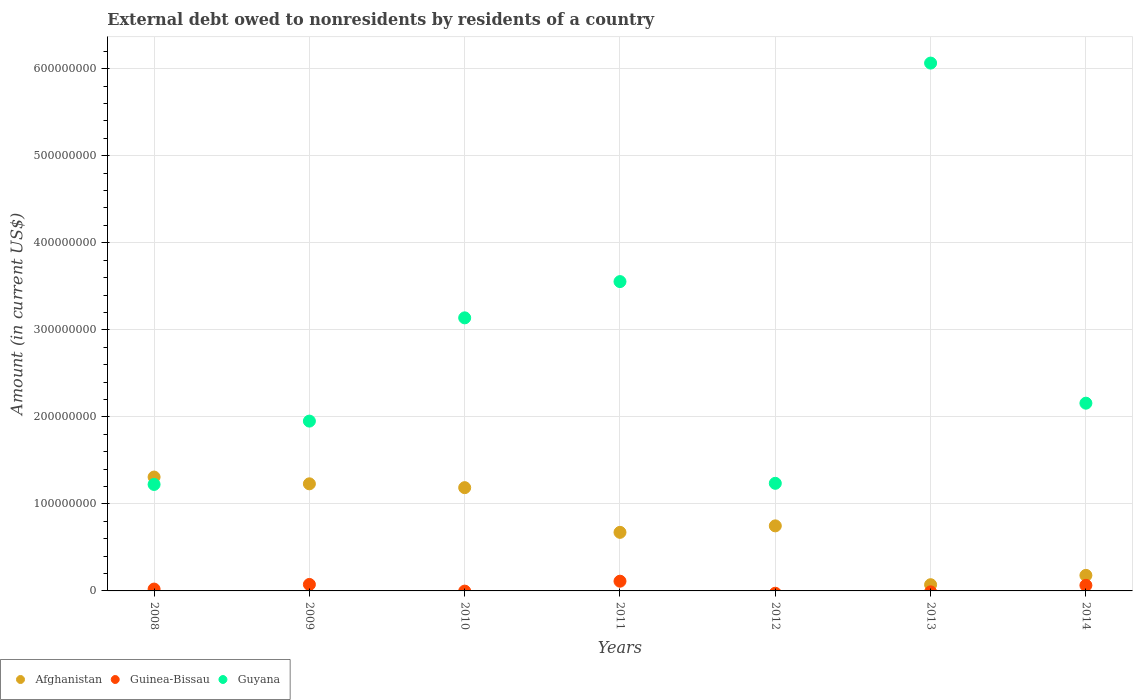How many different coloured dotlines are there?
Provide a succinct answer. 3. Is the number of dotlines equal to the number of legend labels?
Make the answer very short. No. What is the external debt owed by residents in Guyana in 2013?
Your response must be concise. 6.07e+08. Across all years, what is the maximum external debt owed by residents in Guyana?
Provide a succinct answer. 6.07e+08. Across all years, what is the minimum external debt owed by residents in Guinea-Bissau?
Your answer should be compact. 0. What is the total external debt owed by residents in Afghanistan in the graph?
Ensure brevity in your answer.  5.40e+08. What is the difference between the external debt owed by residents in Afghanistan in 2011 and that in 2013?
Ensure brevity in your answer.  6.02e+07. What is the difference between the external debt owed by residents in Afghanistan in 2014 and the external debt owed by residents in Guyana in 2012?
Offer a very short reply. -1.06e+08. What is the average external debt owed by residents in Guyana per year?
Make the answer very short. 2.76e+08. In the year 2014, what is the difference between the external debt owed by residents in Afghanistan and external debt owed by residents in Guinea-Bissau?
Offer a very short reply. 1.15e+07. In how many years, is the external debt owed by residents in Guinea-Bissau greater than 220000000 US$?
Your answer should be very brief. 0. What is the ratio of the external debt owed by residents in Afghanistan in 2013 to that in 2014?
Ensure brevity in your answer.  0.4. Is the external debt owed by residents in Afghanistan in 2008 less than that in 2010?
Give a very brief answer. No. What is the difference between the highest and the second highest external debt owed by residents in Guyana?
Your answer should be compact. 2.51e+08. What is the difference between the highest and the lowest external debt owed by residents in Guinea-Bissau?
Ensure brevity in your answer.  1.12e+07. Does the external debt owed by residents in Guyana monotonically increase over the years?
Provide a succinct answer. No. How many years are there in the graph?
Provide a short and direct response. 7. What is the title of the graph?
Ensure brevity in your answer.  External debt owed to nonresidents by residents of a country. Does "St. Martin (French part)" appear as one of the legend labels in the graph?
Offer a very short reply. No. What is the label or title of the X-axis?
Give a very brief answer. Years. What is the label or title of the Y-axis?
Offer a very short reply. Amount (in current US$). What is the Amount (in current US$) in Afghanistan in 2008?
Offer a terse response. 1.31e+08. What is the Amount (in current US$) in Guinea-Bissau in 2008?
Offer a terse response. 2.12e+06. What is the Amount (in current US$) of Guyana in 2008?
Make the answer very short. 1.22e+08. What is the Amount (in current US$) of Afghanistan in 2009?
Make the answer very short. 1.23e+08. What is the Amount (in current US$) of Guinea-Bissau in 2009?
Offer a very short reply. 7.44e+06. What is the Amount (in current US$) of Guyana in 2009?
Offer a very short reply. 1.95e+08. What is the Amount (in current US$) in Afghanistan in 2010?
Offer a very short reply. 1.19e+08. What is the Amount (in current US$) in Guinea-Bissau in 2010?
Your answer should be compact. 0. What is the Amount (in current US$) in Guyana in 2010?
Your response must be concise. 3.14e+08. What is the Amount (in current US$) of Afghanistan in 2011?
Make the answer very short. 6.73e+07. What is the Amount (in current US$) in Guinea-Bissau in 2011?
Provide a short and direct response. 1.12e+07. What is the Amount (in current US$) of Guyana in 2011?
Provide a short and direct response. 3.55e+08. What is the Amount (in current US$) of Afghanistan in 2012?
Your answer should be compact. 7.48e+07. What is the Amount (in current US$) in Guinea-Bissau in 2012?
Your answer should be very brief. 0. What is the Amount (in current US$) of Guyana in 2012?
Keep it short and to the point. 1.24e+08. What is the Amount (in current US$) in Afghanistan in 2013?
Make the answer very short. 7.14e+06. What is the Amount (in current US$) of Guinea-Bissau in 2013?
Provide a succinct answer. 0. What is the Amount (in current US$) in Guyana in 2013?
Provide a succinct answer. 6.07e+08. What is the Amount (in current US$) of Afghanistan in 2014?
Keep it short and to the point. 1.79e+07. What is the Amount (in current US$) in Guinea-Bissau in 2014?
Provide a succinct answer. 6.40e+06. What is the Amount (in current US$) in Guyana in 2014?
Give a very brief answer. 2.16e+08. Across all years, what is the maximum Amount (in current US$) in Afghanistan?
Offer a terse response. 1.31e+08. Across all years, what is the maximum Amount (in current US$) in Guinea-Bissau?
Offer a terse response. 1.12e+07. Across all years, what is the maximum Amount (in current US$) of Guyana?
Keep it short and to the point. 6.07e+08. Across all years, what is the minimum Amount (in current US$) in Afghanistan?
Your answer should be compact. 7.14e+06. Across all years, what is the minimum Amount (in current US$) in Guyana?
Give a very brief answer. 1.22e+08. What is the total Amount (in current US$) of Afghanistan in the graph?
Provide a short and direct response. 5.40e+08. What is the total Amount (in current US$) in Guinea-Bissau in the graph?
Your response must be concise. 2.71e+07. What is the total Amount (in current US$) of Guyana in the graph?
Ensure brevity in your answer.  1.93e+09. What is the difference between the Amount (in current US$) in Afghanistan in 2008 and that in 2009?
Your answer should be compact. 7.76e+06. What is the difference between the Amount (in current US$) in Guinea-Bissau in 2008 and that in 2009?
Offer a very short reply. -5.32e+06. What is the difference between the Amount (in current US$) of Guyana in 2008 and that in 2009?
Your response must be concise. -7.28e+07. What is the difference between the Amount (in current US$) in Afghanistan in 2008 and that in 2010?
Ensure brevity in your answer.  1.22e+07. What is the difference between the Amount (in current US$) of Guyana in 2008 and that in 2010?
Make the answer very short. -1.91e+08. What is the difference between the Amount (in current US$) of Afghanistan in 2008 and that in 2011?
Offer a terse response. 6.35e+07. What is the difference between the Amount (in current US$) in Guinea-Bissau in 2008 and that in 2011?
Offer a very short reply. -9.04e+06. What is the difference between the Amount (in current US$) in Guyana in 2008 and that in 2011?
Your answer should be very brief. -2.33e+08. What is the difference between the Amount (in current US$) of Afghanistan in 2008 and that in 2012?
Offer a terse response. 5.61e+07. What is the difference between the Amount (in current US$) in Guyana in 2008 and that in 2012?
Your answer should be very brief. -1.30e+06. What is the difference between the Amount (in current US$) of Afghanistan in 2008 and that in 2013?
Provide a succinct answer. 1.24e+08. What is the difference between the Amount (in current US$) in Guyana in 2008 and that in 2013?
Your response must be concise. -4.84e+08. What is the difference between the Amount (in current US$) in Afghanistan in 2008 and that in 2014?
Give a very brief answer. 1.13e+08. What is the difference between the Amount (in current US$) in Guinea-Bissau in 2008 and that in 2014?
Give a very brief answer. -4.28e+06. What is the difference between the Amount (in current US$) of Guyana in 2008 and that in 2014?
Provide a succinct answer. -9.34e+07. What is the difference between the Amount (in current US$) in Afghanistan in 2009 and that in 2010?
Your response must be concise. 4.41e+06. What is the difference between the Amount (in current US$) in Guyana in 2009 and that in 2010?
Your answer should be compact. -1.19e+08. What is the difference between the Amount (in current US$) in Afghanistan in 2009 and that in 2011?
Make the answer very short. 5.58e+07. What is the difference between the Amount (in current US$) of Guinea-Bissau in 2009 and that in 2011?
Provide a short and direct response. -3.73e+06. What is the difference between the Amount (in current US$) in Guyana in 2009 and that in 2011?
Offer a very short reply. -1.60e+08. What is the difference between the Amount (in current US$) in Afghanistan in 2009 and that in 2012?
Make the answer very short. 4.83e+07. What is the difference between the Amount (in current US$) of Guyana in 2009 and that in 2012?
Provide a short and direct response. 7.15e+07. What is the difference between the Amount (in current US$) of Afghanistan in 2009 and that in 2013?
Your answer should be compact. 1.16e+08. What is the difference between the Amount (in current US$) of Guyana in 2009 and that in 2013?
Your answer should be very brief. -4.11e+08. What is the difference between the Amount (in current US$) in Afghanistan in 2009 and that in 2014?
Your answer should be very brief. 1.05e+08. What is the difference between the Amount (in current US$) of Guinea-Bissau in 2009 and that in 2014?
Give a very brief answer. 1.04e+06. What is the difference between the Amount (in current US$) of Guyana in 2009 and that in 2014?
Ensure brevity in your answer.  -2.06e+07. What is the difference between the Amount (in current US$) of Afghanistan in 2010 and that in 2011?
Provide a short and direct response. 5.14e+07. What is the difference between the Amount (in current US$) of Guyana in 2010 and that in 2011?
Offer a very short reply. -4.17e+07. What is the difference between the Amount (in current US$) in Afghanistan in 2010 and that in 2012?
Keep it short and to the point. 4.39e+07. What is the difference between the Amount (in current US$) in Guyana in 2010 and that in 2012?
Your response must be concise. 1.90e+08. What is the difference between the Amount (in current US$) in Afghanistan in 2010 and that in 2013?
Ensure brevity in your answer.  1.12e+08. What is the difference between the Amount (in current US$) of Guyana in 2010 and that in 2013?
Offer a very short reply. -2.93e+08. What is the difference between the Amount (in current US$) of Afghanistan in 2010 and that in 2014?
Provide a short and direct response. 1.01e+08. What is the difference between the Amount (in current US$) of Guyana in 2010 and that in 2014?
Offer a terse response. 9.80e+07. What is the difference between the Amount (in current US$) in Afghanistan in 2011 and that in 2012?
Keep it short and to the point. -7.45e+06. What is the difference between the Amount (in current US$) of Guyana in 2011 and that in 2012?
Give a very brief answer. 2.32e+08. What is the difference between the Amount (in current US$) in Afghanistan in 2011 and that in 2013?
Ensure brevity in your answer.  6.02e+07. What is the difference between the Amount (in current US$) in Guyana in 2011 and that in 2013?
Offer a very short reply. -2.51e+08. What is the difference between the Amount (in current US$) of Afghanistan in 2011 and that in 2014?
Your answer should be compact. 4.94e+07. What is the difference between the Amount (in current US$) in Guinea-Bissau in 2011 and that in 2014?
Ensure brevity in your answer.  4.76e+06. What is the difference between the Amount (in current US$) of Guyana in 2011 and that in 2014?
Make the answer very short. 1.40e+08. What is the difference between the Amount (in current US$) in Afghanistan in 2012 and that in 2013?
Your response must be concise. 6.76e+07. What is the difference between the Amount (in current US$) of Guyana in 2012 and that in 2013?
Provide a succinct answer. -4.83e+08. What is the difference between the Amount (in current US$) of Afghanistan in 2012 and that in 2014?
Keep it short and to the point. 5.69e+07. What is the difference between the Amount (in current US$) of Guyana in 2012 and that in 2014?
Ensure brevity in your answer.  -9.21e+07. What is the difference between the Amount (in current US$) of Afghanistan in 2013 and that in 2014?
Ensure brevity in your answer.  -1.07e+07. What is the difference between the Amount (in current US$) in Guyana in 2013 and that in 2014?
Make the answer very short. 3.91e+08. What is the difference between the Amount (in current US$) in Afghanistan in 2008 and the Amount (in current US$) in Guinea-Bissau in 2009?
Provide a short and direct response. 1.23e+08. What is the difference between the Amount (in current US$) of Afghanistan in 2008 and the Amount (in current US$) of Guyana in 2009?
Your answer should be very brief. -6.43e+07. What is the difference between the Amount (in current US$) of Guinea-Bissau in 2008 and the Amount (in current US$) of Guyana in 2009?
Your answer should be very brief. -1.93e+08. What is the difference between the Amount (in current US$) of Afghanistan in 2008 and the Amount (in current US$) of Guyana in 2010?
Offer a very short reply. -1.83e+08. What is the difference between the Amount (in current US$) of Guinea-Bissau in 2008 and the Amount (in current US$) of Guyana in 2010?
Provide a short and direct response. -3.12e+08. What is the difference between the Amount (in current US$) in Afghanistan in 2008 and the Amount (in current US$) in Guinea-Bissau in 2011?
Offer a terse response. 1.20e+08. What is the difference between the Amount (in current US$) of Afghanistan in 2008 and the Amount (in current US$) of Guyana in 2011?
Provide a short and direct response. -2.25e+08. What is the difference between the Amount (in current US$) in Guinea-Bissau in 2008 and the Amount (in current US$) in Guyana in 2011?
Ensure brevity in your answer.  -3.53e+08. What is the difference between the Amount (in current US$) of Afghanistan in 2008 and the Amount (in current US$) of Guyana in 2012?
Your response must be concise. 7.18e+06. What is the difference between the Amount (in current US$) of Guinea-Bissau in 2008 and the Amount (in current US$) of Guyana in 2012?
Keep it short and to the point. -1.22e+08. What is the difference between the Amount (in current US$) of Afghanistan in 2008 and the Amount (in current US$) of Guyana in 2013?
Your answer should be very brief. -4.76e+08. What is the difference between the Amount (in current US$) in Guinea-Bissau in 2008 and the Amount (in current US$) in Guyana in 2013?
Your response must be concise. -6.04e+08. What is the difference between the Amount (in current US$) of Afghanistan in 2008 and the Amount (in current US$) of Guinea-Bissau in 2014?
Offer a very short reply. 1.24e+08. What is the difference between the Amount (in current US$) of Afghanistan in 2008 and the Amount (in current US$) of Guyana in 2014?
Provide a short and direct response. -8.49e+07. What is the difference between the Amount (in current US$) in Guinea-Bissau in 2008 and the Amount (in current US$) in Guyana in 2014?
Ensure brevity in your answer.  -2.14e+08. What is the difference between the Amount (in current US$) in Afghanistan in 2009 and the Amount (in current US$) in Guyana in 2010?
Give a very brief answer. -1.91e+08. What is the difference between the Amount (in current US$) of Guinea-Bissau in 2009 and the Amount (in current US$) of Guyana in 2010?
Offer a terse response. -3.06e+08. What is the difference between the Amount (in current US$) in Afghanistan in 2009 and the Amount (in current US$) in Guinea-Bissau in 2011?
Ensure brevity in your answer.  1.12e+08. What is the difference between the Amount (in current US$) in Afghanistan in 2009 and the Amount (in current US$) in Guyana in 2011?
Give a very brief answer. -2.32e+08. What is the difference between the Amount (in current US$) of Guinea-Bissau in 2009 and the Amount (in current US$) of Guyana in 2011?
Offer a terse response. -3.48e+08. What is the difference between the Amount (in current US$) in Afghanistan in 2009 and the Amount (in current US$) in Guyana in 2012?
Your response must be concise. -5.81e+05. What is the difference between the Amount (in current US$) of Guinea-Bissau in 2009 and the Amount (in current US$) of Guyana in 2012?
Make the answer very short. -1.16e+08. What is the difference between the Amount (in current US$) in Afghanistan in 2009 and the Amount (in current US$) in Guyana in 2013?
Provide a short and direct response. -4.83e+08. What is the difference between the Amount (in current US$) in Guinea-Bissau in 2009 and the Amount (in current US$) in Guyana in 2013?
Provide a short and direct response. -5.99e+08. What is the difference between the Amount (in current US$) of Afghanistan in 2009 and the Amount (in current US$) of Guinea-Bissau in 2014?
Offer a very short reply. 1.17e+08. What is the difference between the Amount (in current US$) in Afghanistan in 2009 and the Amount (in current US$) in Guyana in 2014?
Provide a succinct answer. -9.27e+07. What is the difference between the Amount (in current US$) of Guinea-Bissau in 2009 and the Amount (in current US$) of Guyana in 2014?
Provide a succinct answer. -2.08e+08. What is the difference between the Amount (in current US$) in Afghanistan in 2010 and the Amount (in current US$) in Guinea-Bissau in 2011?
Offer a terse response. 1.07e+08. What is the difference between the Amount (in current US$) in Afghanistan in 2010 and the Amount (in current US$) in Guyana in 2011?
Keep it short and to the point. -2.37e+08. What is the difference between the Amount (in current US$) of Afghanistan in 2010 and the Amount (in current US$) of Guyana in 2012?
Your answer should be compact. -4.99e+06. What is the difference between the Amount (in current US$) in Afghanistan in 2010 and the Amount (in current US$) in Guyana in 2013?
Give a very brief answer. -4.88e+08. What is the difference between the Amount (in current US$) in Afghanistan in 2010 and the Amount (in current US$) in Guinea-Bissau in 2014?
Keep it short and to the point. 1.12e+08. What is the difference between the Amount (in current US$) in Afghanistan in 2010 and the Amount (in current US$) in Guyana in 2014?
Your response must be concise. -9.71e+07. What is the difference between the Amount (in current US$) of Afghanistan in 2011 and the Amount (in current US$) of Guyana in 2012?
Keep it short and to the point. -5.63e+07. What is the difference between the Amount (in current US$) in Guinea-Bissau in 2011 and the Amount (in current US$) in Guyana in 2012?
Keep it short and to the point. -1.12e+08. What is the difference between the Amount (in current US$) in Afghanistan in 2011 and the Amount (in current US$) in Guyana in 2013?
Provide a succinct answer. -5.39e+08. What is the difference between the Amount (in current US$) of Guinea-Bissau in 2011 and the Amount (in current US$) of Guyana in 2013?
Ensure brevity in your answer.  -5.95e+08. What is the difference between the Amount (in current US$) of Afghanistan in 2011 and the Amount (in current US$) of Guinea-Bissau in 2014?
Keep it short and to the point. 6.09e+07. What is the difference between the Amount (in current US$) of Afghanistan in 2011 and the Amount (in current US$) of Guyana in 2014?
Offer a very short reply. -1.48e+08. What is the difference between the Amount (in current US$) of Guinea-Bissau in 2011 and the Amount (in current US$) of Guyana in 2014?
Ensure brevity in your answer.  -2.05e+08. What is the difference between the Amount (in current US$) of Afghanistan in 2012 and the Amount (in current US$) of Guyana in 2013?
Give a very brief answer. -5.32e+08. What is the difference between the Amount (in current US$) of Afghanistan in 2012 and the Amount (in current US$) of Guinea-Bissau in 2014?
Ensure brevity in your answer.  6.83e+07. What is the difference between the Amount (in current US$) of Afghanistan in 2012 and the Amount (in current US$) of Guyana in 2014?
Your answer should be compact. -1.41e+08. What is the difference between the Amount (in current US$) in Afghanistan in 2013 and the Amount (in current US$) in Guinea-Bissau in 2014?
Your response must be concise. 7.35e+05. What is the difference between the Amount (in current US$) of Afghanistan in 2013 and the Amount (in current US$) of Guyana in 2014?
Make the answer very short. -2.09e+08. What is the average Amount (in current US$) of Afghanistan per year?
Make the answer very short. 7.71e+07. What is the average Amount (in current US$) of Guinea-Bissau per year?
Make the answer very short. 3.88e+06. What is the average Amount (in current US$) in Guyana per year?
Keep it short and to the point. 2.76e+08. In the year 2008, what is the difference between the Amount (in current US$) in Afghanistan and Amount (in current US$) in Guinea-Bissau?
Offer a terse response. 1.29e+08. In the year 2008, what is the difference between the Amount (in current US$) of Afghanistan and Amount (in current US$) of Guyana?
Provide a succinct answer. 8.48e+06. In the year 2008, what is the difference between the Amount (in current US$) of Guinea-Bissau and Amount (in current US$) of Guyana?
Provide a short and direct response. -1.20e+08. In the year 2009, what is the difference between the Amount (in current US$) in Afghanistan and Amount (in current US$) in Guinea-Bissau?
Your answer should be very brief. 1.16e+08. In the year 2009, what is the difference between the Amount (in current US$) of Afghanistan and Amount (in current US$) of Guyana?
Provide a short and direct response. -7.21e+07. In the year 2009, what is the difference between the Amount (in current US$) in Guinea-Bissau and Amount (in current US$) in Guyana?
Your answer should be compact. -1.88e+08. In the year 2010, what is the difference between the Amount (in current US$) in Afghanistan and Amount (in current US$) in Guyana?
Give a very brief answer. -1.95e+08. In the year 2011, what is the difference between the Amount (in current US$) of Afghanistan and Amount (in current US$) of Guinea-Bissau?
Offer a terse response. 5.61e+07. In the year 2011, what is the difference between the Amount (in current US$) of Afghanistan and Amount (in current US$) of Guyana?
Your answer should be very brief. -2.88e+08. In the year 2011, what is the difference between the Amount (in current US$) in Guinea-Bissau and Amount (in current US$) in Guyana?
Give a very brief answer. -3.44e+08. In the year 2012, what is the difference between the Amount (in current US$) in Afghanistan and Amount (in current US$) in Guyana?
Give a very brief answer. -4.89e+07. In the year 2013, what is the difference between the Amount (in current US$) in Afghanistan and Amount (in current US$) in Guyana?
Ensure brevity in your answer.  -5.99e+08. In the year 2014, what is the difference between the Amount (in current US$) in Afghanistan and Amount (in current US$) in Guinea-Bissau?
Provide a succinct answer. 1.15e+07. In the year 2014, what is the difference between the Amount (in current US$) in Afghanistan and Amount (in current US$) in Guyana?
Keep it short and to the point. -1.98e+08. In the year 2014, what is the difference between the Amount (in current US$) of Guinea-Bissau and Amount (in current US$) of Guyana?
Your answer should be very brief. -2.09e+08. What is the ratio of the Amount (in current US$) of Afghanistan in 2008 to that in 2009?
Your answer should be very brief. 1.06. What is the ratio of the Amount (in current US$) in Guinea-Bissau in 2008 to that in 2009?
Your answer should be very brief. 0.29. What is the ratio of the Amount (in current US$) in Guyana in 2008 to that in 2009?
Your response must be concise. 0.63. What is the ratio of the Amount (in current US$) in Afghanistan in 2008 to that in 2010?
Offer a very short reply. 1.1. What is the ratio of the Amount (in current US$) in Guyana in 2008 to that in 2010?
Ensure brevity in your answer.  0.39. What is the ratio of the Amount (in current US$) of Afghanistan in 2008 to that in 2011?
Offer a very short reply. 1.94. What is the ratio of the Amount (in current US$) in Guinea-Bissau in 2008 to that in 2011?
Provide a short and direct response. 0.19. What is the ratio of the Amount (in current US$) of Guyana in 2008 to that in 2011?
Give a very brief answer. 0.34. What is the ratio of the Amount (in current US$) in Afghanistan in 2008 to that in 2012?
Your response must be concise. 1.75. What is the ratio of the Amount (in current US$) of Afghanistan in 2008 to that in 2013?
Your answer should be very brief. 18.33. What is the ratio of the Amount (in current US$) in Guyana in 2008 to that in 2013?
Keep it short and to the point. 0.2. What is the ratio of the Amount (in current US$) in Afghanistan in 2008 to that in 2014?
Provide a short and direct response. 7.32. What is the ratio of the Amount (in current US$) of Guinea-Bissau in 2008 to that in 2014?
Your answer should be very brief. 0.33. What is the ratio of the Amount (in current US$) of Guyana in 2008 to that in 2014?
Offer a terse response. 0.57. What is the ratio of the Amount (in current US$) in Afghanistan in 2009 to that in 2010?
Offer a terse response. 1.04. What is the ratio of the Amount (in current US$) in Guyana in 2009 to that in 2010?
Your answer should be compact. 0.62. What is the ratio of the Amount (in current US$) in Afghanistan in 2009 to that in 2011?
Give a very brief answer. 1.83. What is the ratio of the Amount (in current US$) in Guinea-Bissau in 2009 to that in 2011?
Ensure brevity in your answer.  0.67. What is the ratio of the Amount (in current US$) in Guyana in 2009 to that in 2011?
Offer a very short reply. 0.55. What is the ratio of the Amount (in current US$) of Afghanistan in 2009 to that in 2012?
Give a very brief answer. 1.65. What is the ratio of the Amount (in current US$) of Guyana in 2009 to that in 2012?
Your answer should be compact. 1.58. What is the ratio of the Amount (in current US$) in Afghanistan in 2009 to that in 2013?
Provide a succinct answer. 17.24. What is the ratio of the Amount (in current US$) in Guyana in 2009 to that in 2013?
Offer a very short reply. 0.32. What is the ratio of the Amount (in current US$) of Afghanistan in 2009 to that in 2014?
Ensure brevity in your answer.  6.89. What is the ratio of the Amount (in current US$) in Guinea-Bissau in 2009 to that in 2014?
Provide a short and direct response. 1.16. What is the ratio of the Amount (in current US$) of Guyana in 2009 to that in 2014?
Your answer should be compact. 0.9. What is the ratio of the Amount (in current US$) of Afghanistan in 2010 to that in 2011?
Make the answer very short. 1.76. What is the ratio of the Amount (in current US$) in Guyana in 2010 to that in 2011?
Provide a succinct answer. 0.88. What is the ratio of the Amount (in current US$) in Afghanistan in 2010 to that in 2012?
Make the answer very short. 1.59. What is the ratio of the Amount (in current US$) of Guyana in 2010 to that in 2012?
Your answer should be very brief. 2.54. What is the ratio of the Amount (in current US$) of Afghanistan in 2010 to that in 2013?
Ensure brevity in your answer.  16.62. What is the ratio of the Amount (in current US$) of Guyana in 2010 to that in 2013?
Your response must be concise. 0.52. What is the ratio of the Amount (in current US$) in Afghanistan in 2010 to that in 2014?
Provide a succinct answer. 6.64. What is the ratio of the Amount (in current US$) in Guyana in 2010 to that in 2014?
Give a very brief answer. 1.45. What is the ratio of the Amount (in current US$) in Afghanistan in 2011 to that in 2012?
Keep it short and to the point. 0.9. What is the ratio of the Amount (in current US$) in Guyana in 2011 to that in 2012?
Your response must be concise. 2.87. What is the ratio of the Amount (in current US$) in Afghanistan in 2011 to that in 2013?
Give a very brief answer. 9.43. What is the ratio of the Amount (in current US$) in Guyana in 2011 to that in 2013?
Ensure brevity in your answer.  0.59. What is the ratio of the Amount (in current US$) of Afghanistan in 2011 to that in 2014?
Offer a very short reply. 3.77. What is the ratio of the Amount (in current US$) in Guinea-Bissau in 2011 to that in 2014?
Your answer should be compact. 1.74. What is the ratio of the Amount (in current US$) in Guyana in 2011 to that in 2014?
Offer a terse response. 1.65. What is the ratio of the Amount (in current US$) in Afghanistan in 2012 to that in 2013?
Give a very brief answer. 10.47. What is the ratio of the Amount (in current US$) of Guyana in 2012 to that in 2013?
Your answer should be very brief. 0.2. What is the ratio of the Amount (in current US$) in Afghanistan in 2012 to that in 2014?
Provide a short and direct response. 4.18. What is the ratio of the Amount (in current US$) in Guyana in 2012 to that in 2014?
Give a very brief answer. 0.57. What is the ratio of the Amount (in current US$) in Afghanistan in 2013 to that in 2014?
Give a very brief answer. 0.4. What is the ratio of the Amount (in current US$) of Guyana in 2013 to that in 2014?
Keep it short and to the point. 2.81. What is the difference between the highest and the second highest Amount (in current US$) in Afghanistan?
Your answer should be compact. 7.76e+06. What is the difference between the highest and the second highest Amount (in current US$) of Guinea-Bissau?
Offer a terse response. 3.73e+06. What is the difference between the highest and the second highest Amount (in current US$) of Guyana?
Give a very brief answer. 2.51e+08. What is the difference between the highest and the lowest Amount (in current US$) of Afghanistan?
Provide a short and direct response. 1.24e+08. What is the difference between the highest and the lowest Amount (in current US$) of Guinea-Bissau?
Provide a succinct answer. 1.12e+07. What is the difference between the highest and the lowest Amount (in current US$) in Guyana?
Keep it short and to the point. 4.84e+08. 